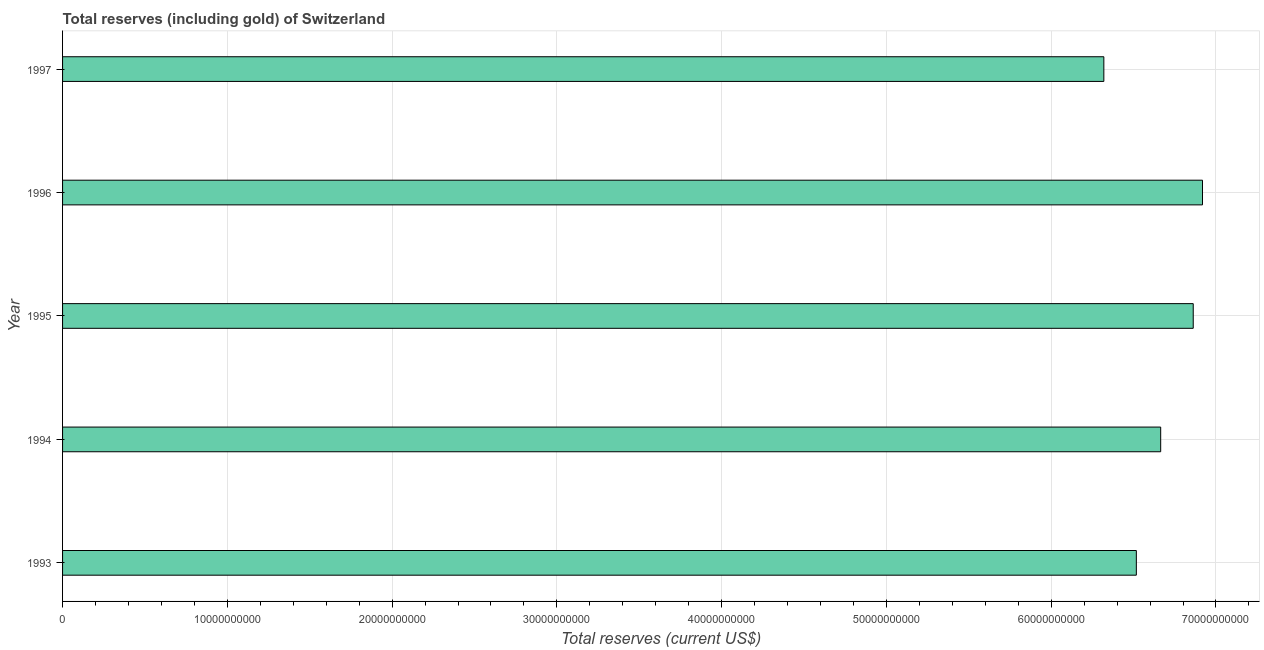Does the graph contain grids?
Offer a terse response. Yes. What is the title of the graph?
Keep it short and to the point. Total reserves (including gold) of Switzerland. What is the label or title of the X-axis?
Offer a very short reply. Total reserves (current US$). What is the total reserves (including gold) in 1994?
Provide a short and direct response. 6.66e+1. Across all years, what is the maximum total reserves (including gold)?
Ensure brevity in your answer.  6.92e+1. Across all years, what is the minimum total reserves (including gold)?
Your answer should be compact. 6.32e+1. In which year was the total reserves (including gold) minimum?
Make the answer very short. 1997. What is the sum of the total reserves (including gold)?
Your answer should be very brief. 3.33e+11. What is the difference between the total reserves (including gold) in 1993 and 1996?
Your response must be concise. -4.02e+09. What is the average total reserves (including gold) per year?
Offer a very short reply. 6.66e+1. What is the median total reserves (including gold)?
Your answer should be compact. 6.66e+1. In how many years, is the total reserves (including gold) greater than 58000000000 US$?
Keep it short and to the point. 5. What is the ratio of the total reserves (including gold) in 1996 to that in 1997?
Provide a short and direct response. 1.09. Is the total reserves (including gold) in 1993 less than that in 1994?
Your answer should be very brief. Yes. Is the difference between the total reserves (including gold) in 1993 and 1995 greater than the difference between any two years?
Your answer should be compact. No. What is the difference between the highest and the second highest total reserves (including gold)?
Provide a succinct answer. 5.62e+08. What is the difference between the highest and the lowest total reserves (including gold)?
Make the answer very short. 5.99e+09. In how many years, is the total reserves (including gold) greater than the average total reserves (including gold) taken over all years?
Offer a very short reply. 3. How many bars are there?
Ensure brevity in your answer.  5. Are all the bars in the graph horizontal?
Keep it short and to the point. Yes. How many years are there in the graph?
Offer a very short reply. 5. What is the Total reserves (current US$) in 1993?
Offer a terse response. 6.52e+1. What is the Total reserves (current US$) of 1994?
Keep it short and to the point. 6.66e+1. What is the Total reserves (current US$) in 1995?
Provide a short and direct response. 6.86e+1. What is the Total reserves (current US$) of 1996?
Your answer should be compact. 6.92e+1. What is the Total reserves (current US$) of 1997?
Keep it short and to the point. 6.32e+1. What is the difference between the Total reserves (current US$) in 1993 and 1994?
Your answer should be compact. -1.48e+09. What is the difference between the Total reserves (current US$) in 1993 and 1995?
Your answer should be compact. -3.45e+09. What is the difference between the Total reserves (current US$) in 1993 and 1996?
Ensure brevity in your answer.  -4.02e+09. What is the difference between the Total reserves (current US$) in 1993 and 1997?
Give a very brief answer. 1.97e+09. What is the difference between the Total reserves (current US$) in 1994 and 1995?
Give a very brief answer. -1.98e+09. What is the difference between the Total reserves (current US$) in 1994 and 1996?
Your answer should be compact. -2.54e+09. What is the difference between the Total reserves (current US$) in 1994 and 1997?
Keep it short and to the point. 3.45e+09. What is the difference between the Total reserves (current US$) in 1995 and 1996?
Your response must be concise. -5.62e+08. What is the difference between the Total reserves (current US$) in 1995 and 1997?
Offer a terse response. 5.43e+09. What is the difference between the Total reserves (current US$) in 1996 and 1997?
Offer a terse response. 5.99e+09. What is the ratio of the Total reserves (current US$) in 1993 to that in 1996?
Make the answer very short. 0.94. What is the ratio of the Total reserves (current US$) in 1993 to that in 1997?
Offer a very short reply. 1.03. What is the ratio of the Total reserves (current US$) in 1994 to that in 1997?
Offer a very short reply. 1.05. What is the ratio of the Total reserves (current US$) in 1995 to that in 1996?
Ensure brevity in your answer.  0.99. What is the ratio of the Total reserves (current US$) in 1995 to that in 1997?
Ensure brevity in your answer.  1.09. What is the ratio of the Total reserves (current US$) in 1996 to that in 1997?
Offer a very short reply. 1.09. 